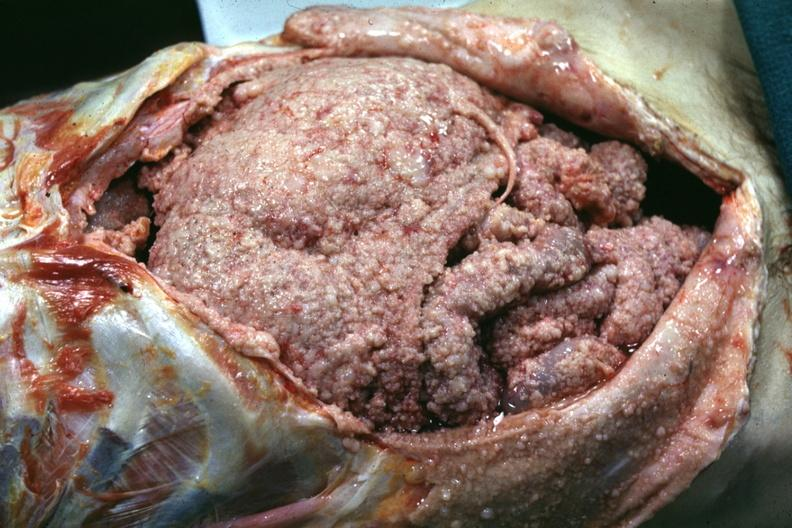does mesothelioma show opened abdomen with neoplasm covering all surfaces?
Answer the question using a single word or phrase. No 